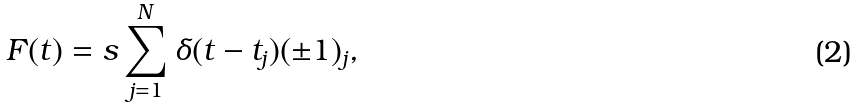<formula> <loc_0><loc_0><loc_500><loc_500>F ( t ) = s \sum _ { j = 1 } ^ { N } \delta ( t - t _ { j } ) ( \pm 1 ) _ { j } ,</formula> 